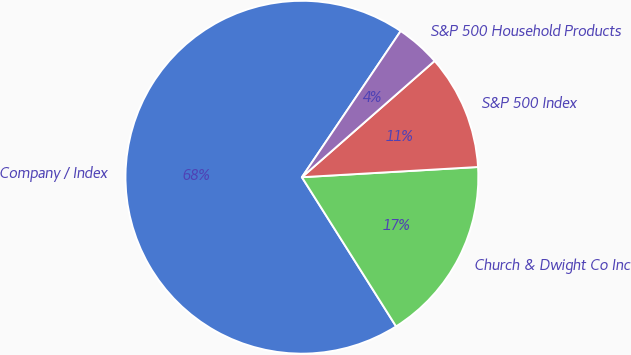Convert chart. <chart><loc_0><loc_0><loc_500><loc_500><pie_chart><fcel>Company / Index<fcel>Church & Dwight Co Inc<fcel>S&P 500 Index<fcel>S&P 500 Household Products<nl><fcel>68.42%<fcel>16.96%<fcel>10.53%<fcel>4.09%<nl></chart> 